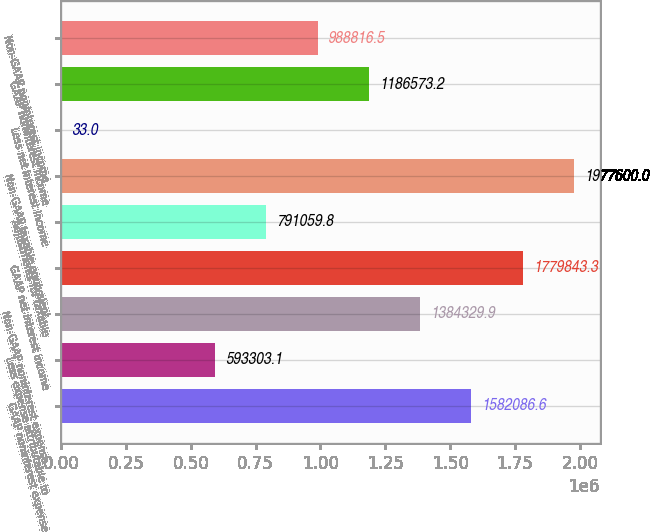<chart> <loc_0><loc_0><loc_500><loc_500><bar_chart><fcel>GAAP noninterest expense<fcel>Less expense attributable to<fcel>Non-GAAP noninterest expense<fcel>GAAP net interest income<fcel>Adjustments for taxable<fcel>Non-GAAP taxable equivalent<fcel>Less net interest income<fcel>GAAP noninterest income<fcel>Non-GAAP noninterest income<nl><fcel>1.58209e+06<fcel>593303<fcel>1.38433e+06<fcel>1.77984e+06<fcel>791060<fcel>1.9776e+06<fcel>33<fcel>1.18657e+06<fcel>988816<nl></chart> 